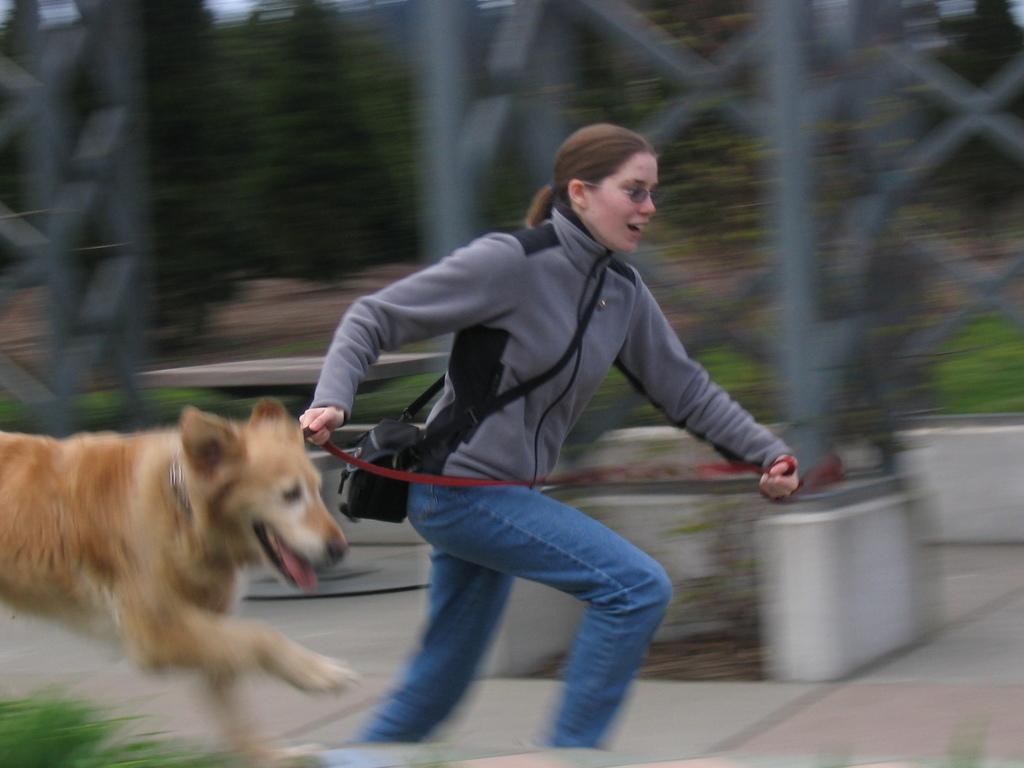In one or two sentences, can you explain what this image depicts? This is a picture taken in the outdoor, the women and a dog running on the floor. Background of this woman is a tower and trees. 